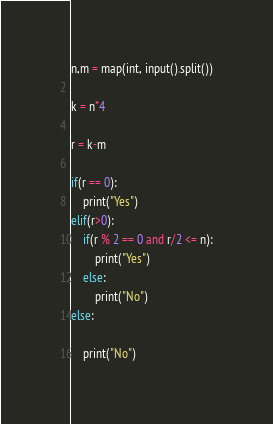Convert code to text. <code><loc_0><loc_0><loc_500><loc_500><_Python_>n,m = map(int, input().split())

k = n*4

r = k-m

if(r == 0):
    print("Yes")
elif(r>0):
    if(r % 2 == 0 and r/2 <= n):
        print("Yes")
    else:
        print("No")
else:
    
    print("No")</code> 